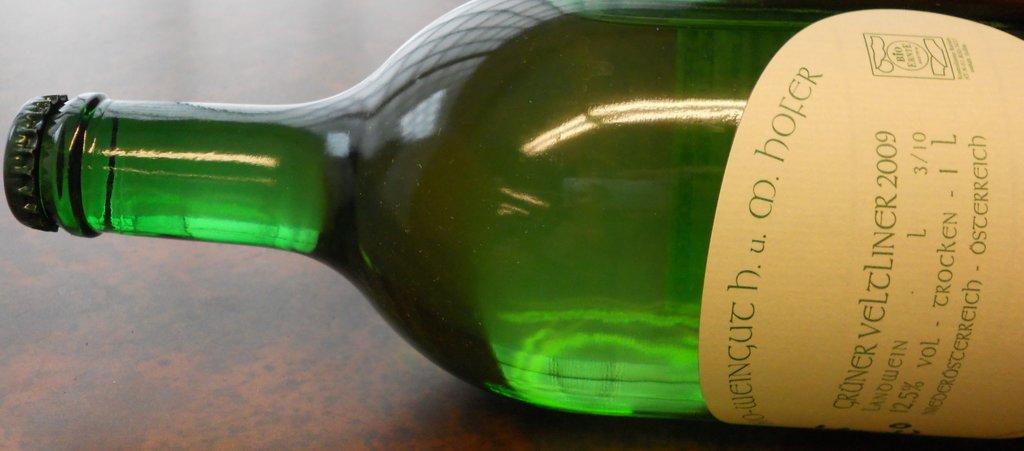What is the year of this wine?
Keep it short and to the point. 2009. What percent alcohol?
Offer a very short reply. 12.5. 